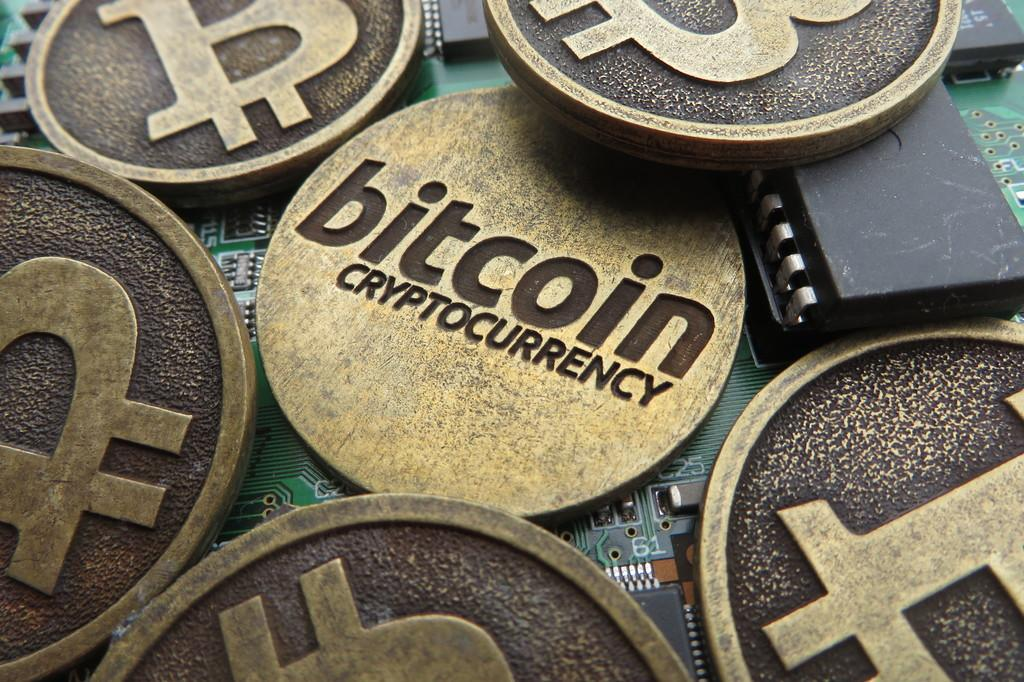What type of coins are visible in the image? There are bronze coins in the image. Where are the bronze coins located? The bronze coins are on an Arduino board. Where is the nest of the bird in the image? There is no bird or nest present in the image; it features bronze coins on an Arduino board. 